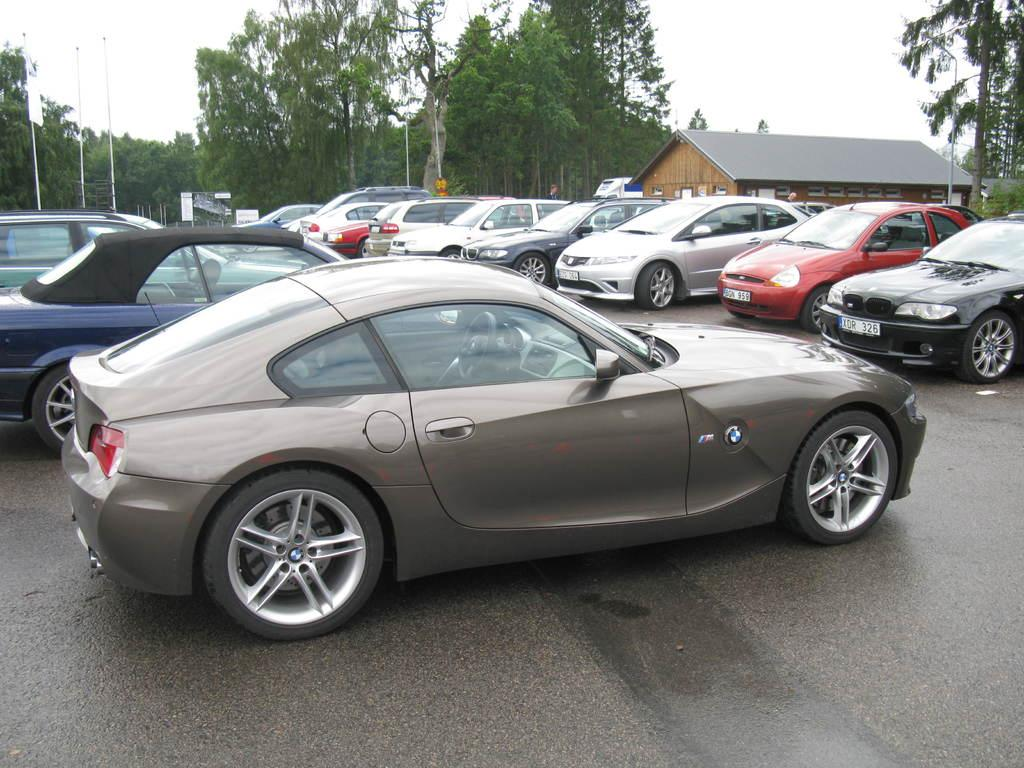What can be seen on the road in the image? There are vehicles parked on the road in the image. What type of structure is visible in the image? There is a house in the image. What is attached to a pole in the image? There is a flag in the image. What are the poles used for in the image? The poles are used to support the flag and other items, such as boards. What type of vegetation is present in the image? There are trees in the image. What part of the natural environment is visible in the image? The sky is visible in the image. What flavor of ring can be seen on the secretary's finger in the image? There is no ring or secretary present in the image. 